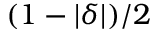Convert formula to latex. <formula><loc_0><loc_0><loc_500><loc_500>( 1 - | \delta | ) / 2</formula> 